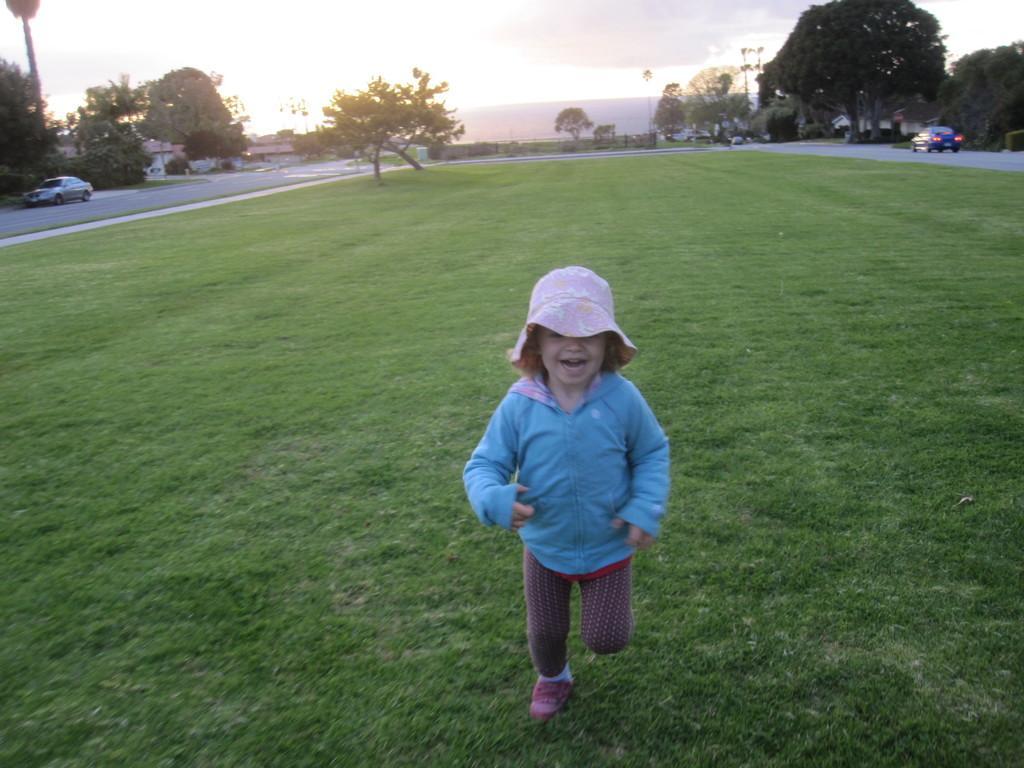Can you describe this image briefly? This image is taken outdoors. At the bottom of the image there is a ground with grass on it. At the top of the image there is the sky with clouds. In the background there are a few trees, houses, plants and poles with street lights. A few vehicles are parked on the road and a car is moving on the road. In the middle of the image a kid is running on the ground. 